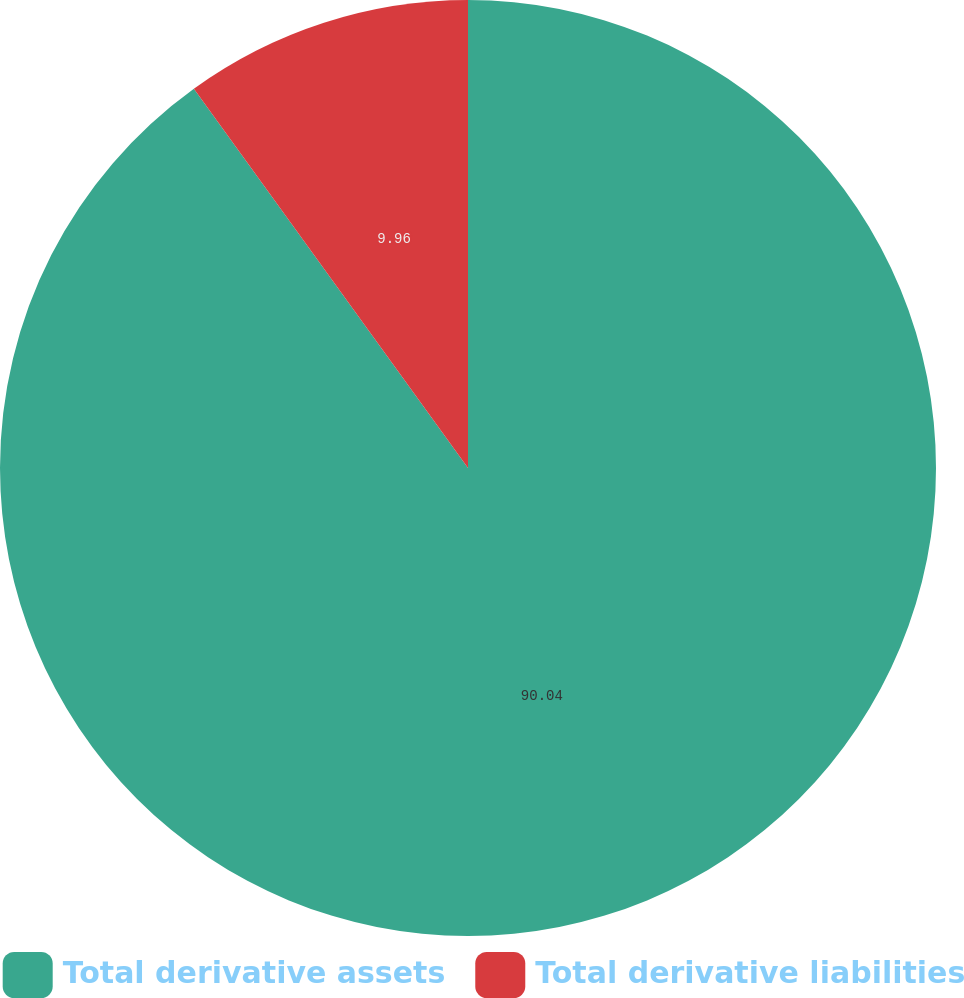Convert chart to OTSL. <chart><loc_0><loc_0><loc_500><loc_500><pie_chart><fcel>Total derivative assets<fcel>Total derivative liabilities<nl><fcel>90.04%<fcel>9.96%<nl></chart> 